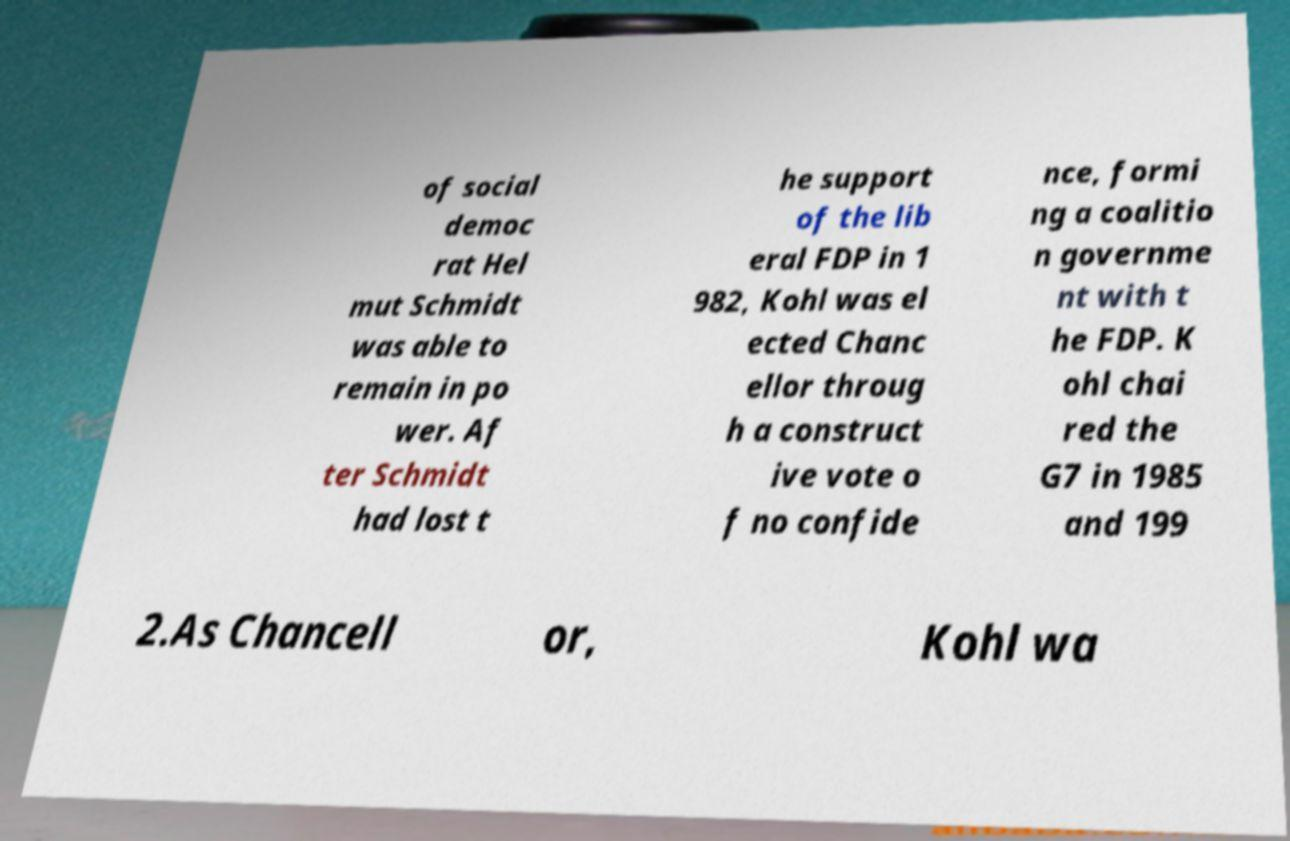Can you accurately transcribe the text from the provided image for me? of social democ rat Hel mut Schmidt was able to remain in po wer. Af ter Schmidt had lost t he support of the lib eral FDP in 1 982, Kohl was el ected Chanc ellor throug h a construct ive vote o f no confide nce, formi ng a coalitio n governme nt with t he FDP. K ohl chai red the G7 in 1985 and 199 2.As Chancell or, Kohl wa 